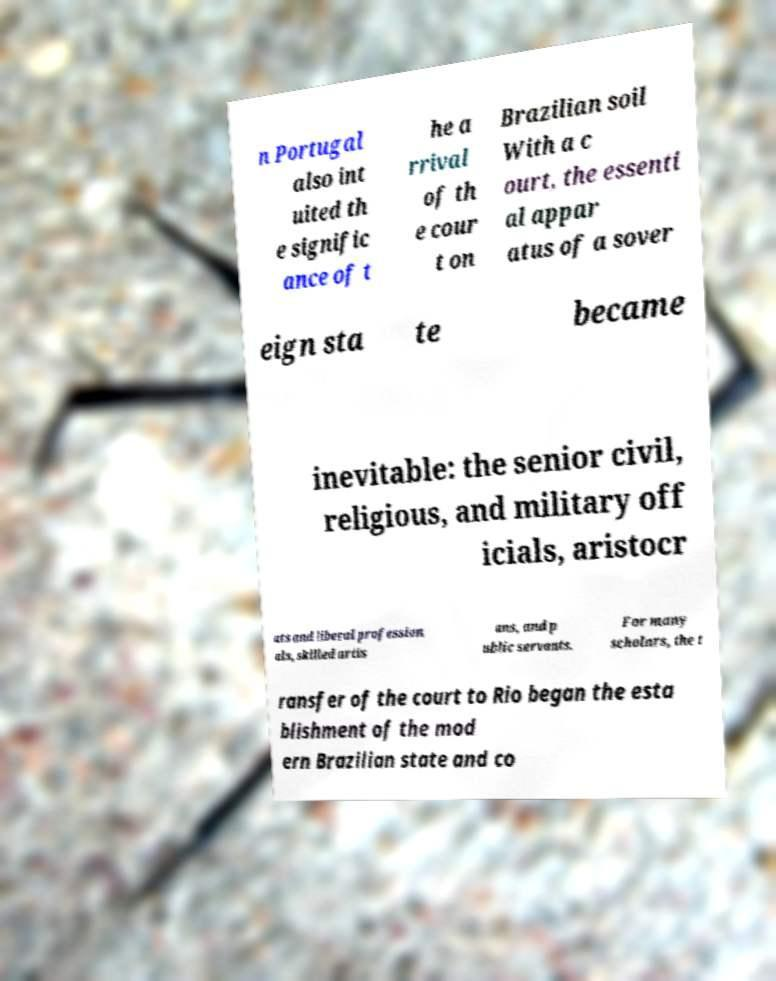For documentation purposes, I need the text within this image transcribed. Could you provide that? n Portugal also int uited th e signific ance of t he a rrival of th e cour t on Brazilian soil With a c ourt, the essenti al appar atus of a sover eign sta te became inevitable: the senior civil, religious, and military off icials, aristocr ats and liberal profession als, skilled artis ans, and p ublic servants. For many scholars, the t ransfer of the court to Rio began the esta blishment of the mod ern Brazilian state and co 